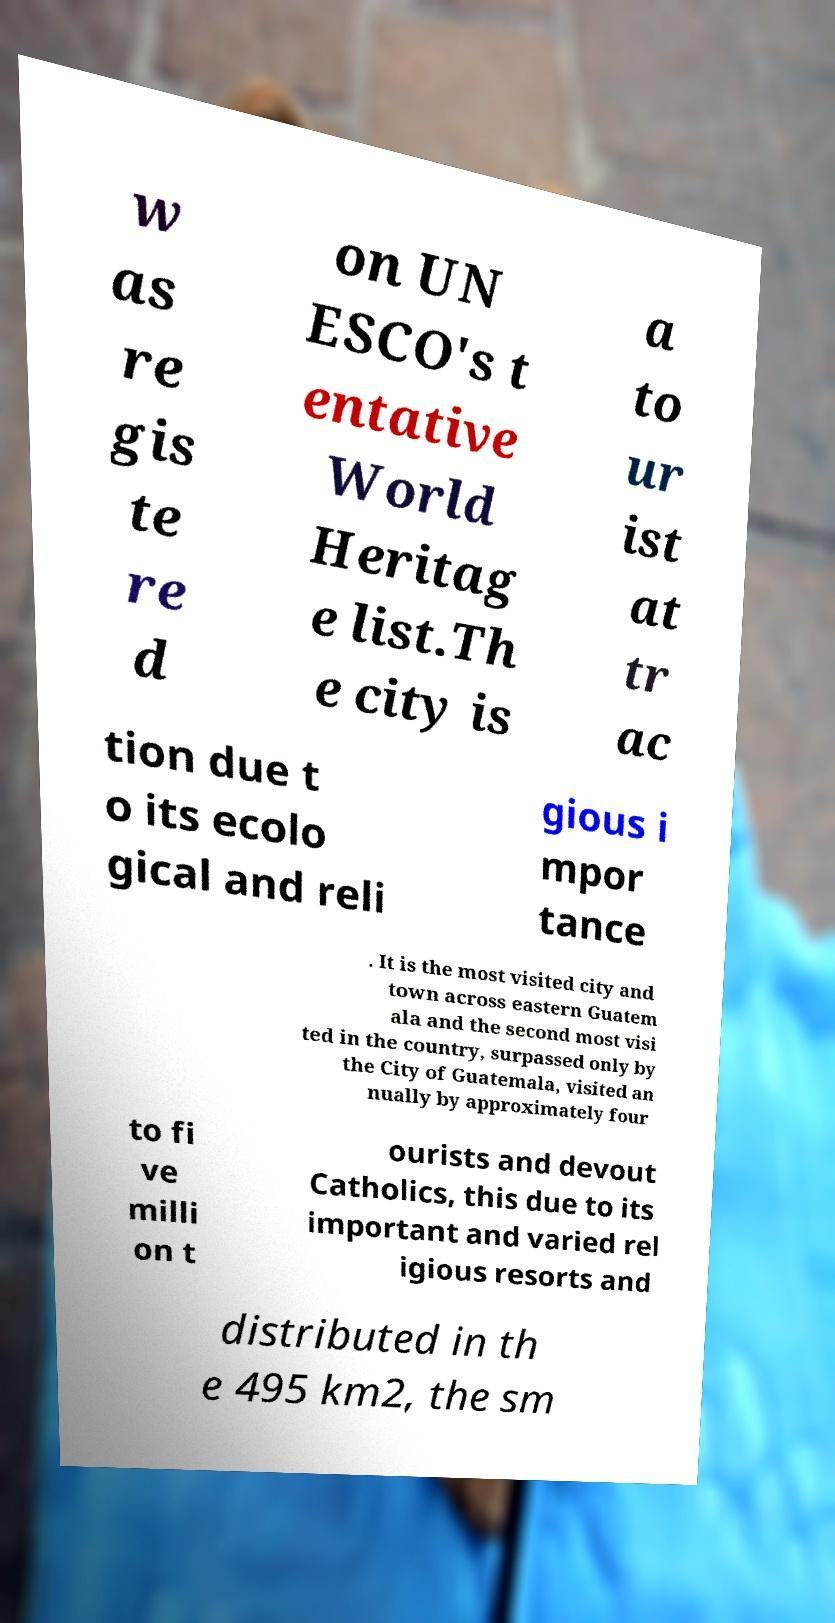I need the written content from this picture converted into text. Can you do that? w as re gis te re d on UN ESCO's t entative World Heritag e list.Th e city is a to ur ist at tr ac tion due t o its ecolo gical and reli gious i mpor tance . It is the most visited city and town across eastern Guatem ala and the second most visi ted in the country, surpassed only by the City of Guatemala, visited an nually by approximately four to fi ve milli on t ourists and devout Catholics, this due to its important and varied rel igious resorts and distributed in th e 495 km2, the sm 